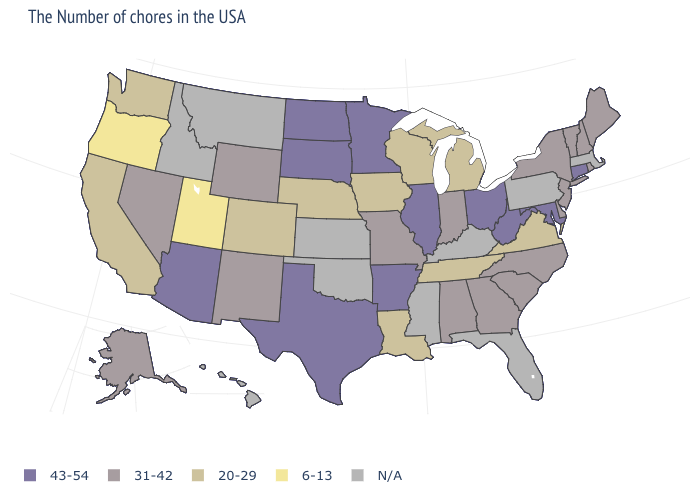What is the lowest value in the West?
Answer briefly. 6-13. Name the states that have a value in the range 6-13?
Be succinct. Utah, Oregon. What is the value of Maine?
Be succinct. 31-42. What is the value of Connecticut?
Keep it brief. 43-54. Name the states that have a value in the range N/A?
Give a very brief answer. Massachusetts, Pennsylvania, Florida, Kentucky, Mississippi, Kansas, Oklahoma, Montana, Idaho, Hawaii. Which states have the lowest value in the USA?
Short answer required. Utah, Oregon. What is the lowest value in states that border Montana?
Keep it brief. 31-42. Does the map have missing data?
Give a very brief answer. Yes. Does Wyoming have the lowest value in the West?
Be succinct. No. Name the states that have a value in the range 31-42?
Be succinct. Maine, Rhode Island, New Hampshire, Vermont, New York, New Jersey, Delaware, North Carolina, South Carolina, Georgia, Indiana, Alabama, Missouri, Wyoming, New Mexico, Nevada, Alaska. Among the states that border Texas , does Arkansas have the highest value?
Give a very brief answer. Yes. Does South Carolina have the highest value in the South?
Answer briefly. No. Name the states that have a value in the range 31-42?
Give a very brief answer. Maine, Rhode Island, New Hampshire, Vermont, New York, New Jersey, Delaware, North Carolina, South Carolina, Georgia, Indiana, Alabama, Missouri, Wyoming, New Mexico, Nevada, Alaska. 